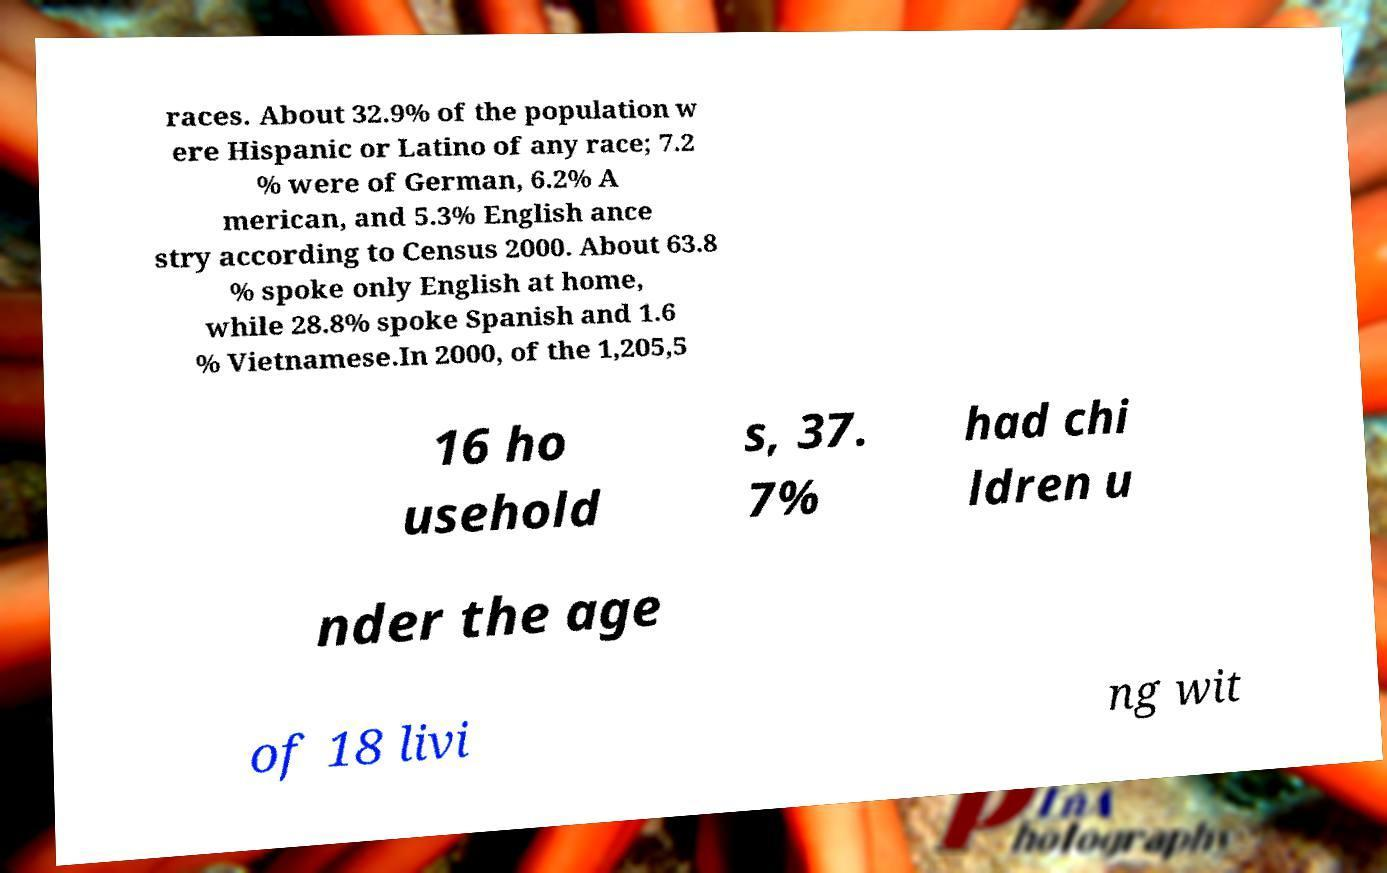Can you read and provide the text displayed in the image?This photo seems to have some interesting text. Can you extract and type it out for me? races. About 32.9% of the population w ere Hispanic or Latino of any race; 7.2 % were of German, 6.2% A merican, and 5.3% English ance stry according to Census 2000. About 63.8 % spoke only English at home, while 28.8% spoke Spanish and 1.6 % Vietnamese.In 2000, of the 1,205,5 16 ho usehold s, 37. 7% had chi ldren u nder the age of 18 livi ng wit 